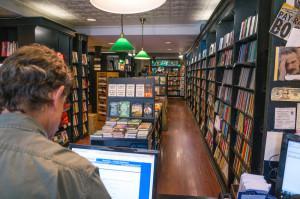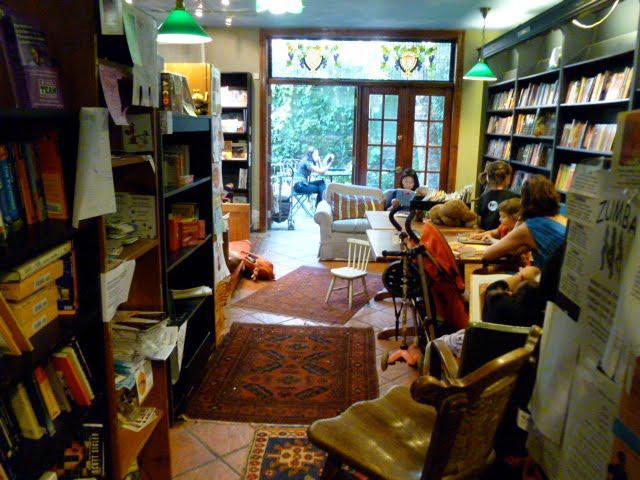The first image is the image on the left, the second image is the image on the right. Assess this claim about the two images: "wooden french doors are open and visible from the inside of the store". Correct or not? Answer yes or no. Yes. The first image is the image on the left, the second image is the image on the right. Analyze the images presented: Is the assertion "There is a stained glass window visible over the doorway." valid? Answer yes or no. Yes. 